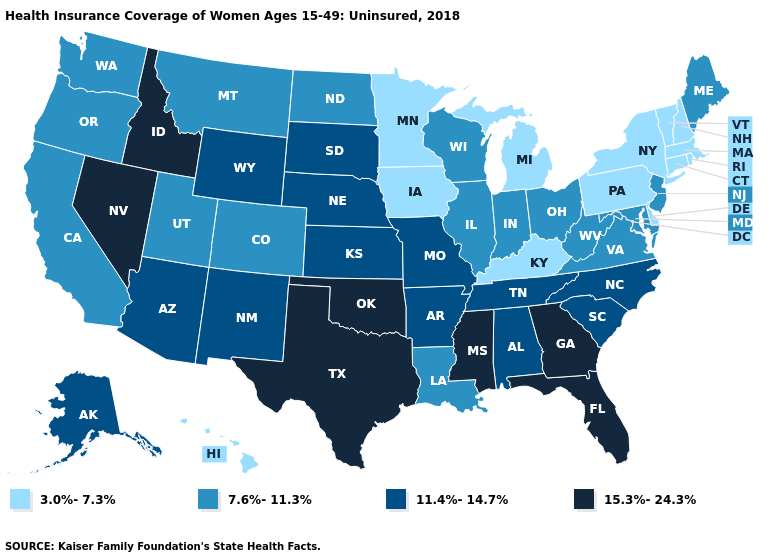Does the first symbol in the legend represent the smallest category?
Short answer required. Yes. What is the lowest value in the West?
Give a very brief answer. 3.0%-7.3%. Which states hav the highest value in the South?
Keep it brief. Florida, Georgia, Mississippi, Oklahoma, Texas. What is the lowest value in the USA?
Be succinct. 3.0%-7.3%. Does New Hampshire have the lowest value in the USA?
Give a very brief answer. Yes. Which states hav the highest value in the MidWest?
Short answer required. Kansas, Missouri, Nebraska, South Dakota. Which states have the lowest value in the South?
Give a very brief answer. Delaware, Kentucky. Does Kentucky have the lowest value in the South?
Keep it brief. Yes. What is the highest value in the USA?
Quick response, please. 15.3%-24.3%. Does Alabama have a higher value than Colorado?
Concise answer only. Yes. Name the states that have a value in the range 11.4%-14.7%?
Write a very short answer. Alabama, Alaska, Arizona, Arkansas, Kansas, Missouri, Nebraska, New Mexico, North Carolina, South Carolina, South Dakota, Tennessee, Wyoming. What is the value of Nevada?
Write a very short answer. 15.3%-24.3%. What is the highest value in states that border Arizona?
Keep it brief. 15.3%-24.3%. Name the states that have a value in the range 3.0%-7.3%?
Give a very brief answer. Connecticut, Delaware, Hawaii, Iowa, Kentucky, Massachusetts, Michigan, Minnesota, New Hampshire, New York, Pennsylvania, Rhode Island, Vermont. What is the lowest value in states that border West Virginia?
Be succinct. 3.0%-7.3%. 